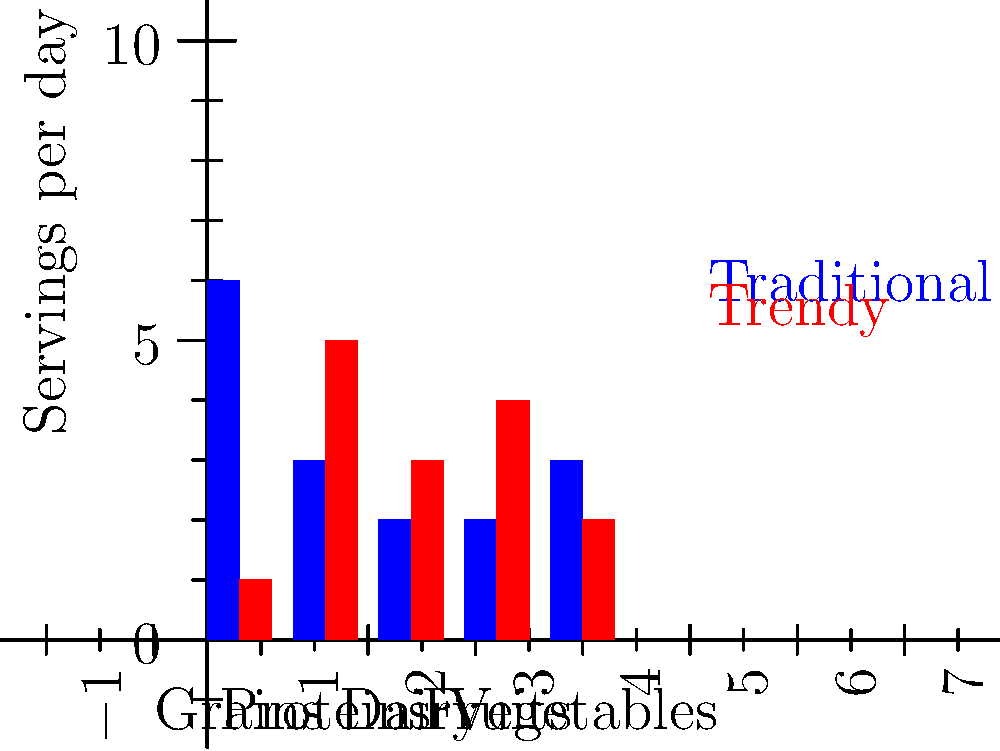Based on the bar graph comparing the nutritional content of a traditional food pyramid versus a trendy diet plan, which statement is most likely to be supported by a registered dietitian who advocates for traditional dietary guidelines? To answer this question, let's analyze the graph and consider the perspective of a registered dietitian who advocates for traditional dietary guidelines:

1. Grains: The traditional plan recommends 6 servings per day, while the trendy plan only recommends 1. This is a significant difference.

2. Proteins: The trendy plan recommends 5 servings, compared to 3 in the traditional plan. This is a notable increase.

3. Dairy: The trendy plan slightly increases dairy intake from 2 to 3 servings.

4. Fruits: The trendy plan doubles fruit intake from 2 to 4 servings.

5. Vegetables: The trendy plan slightly decreases vegetable intake from 3 to 2 servings.

A registered dietitian advocating for traditional guidelines would likely be concerned about:

1. The drastic reduction in grain intake, which contradicts the base of the traditional food pyramid.
2. The significant increase in protein intake, which may be excessive for most people.
3. The slight decrease in vegetable intake, as vegetables are generally encouraged in most dietary guidelines.

While the increase in fruit intake might be seen as positive, the overall balance of the trendy diet plan deviates significantly from traditional recommendations.

Therefore, a dietitian adhering to traditional guidelines would likely argue that the trendy diet plan lacks the balanced approach of the traditional food pyramid, particularly in its treatment of grains and proteins.
Answer: The trendy diet plan lacks balance and may lead to nutritional deficiencies, particularly due to its low grain and high protein content. 